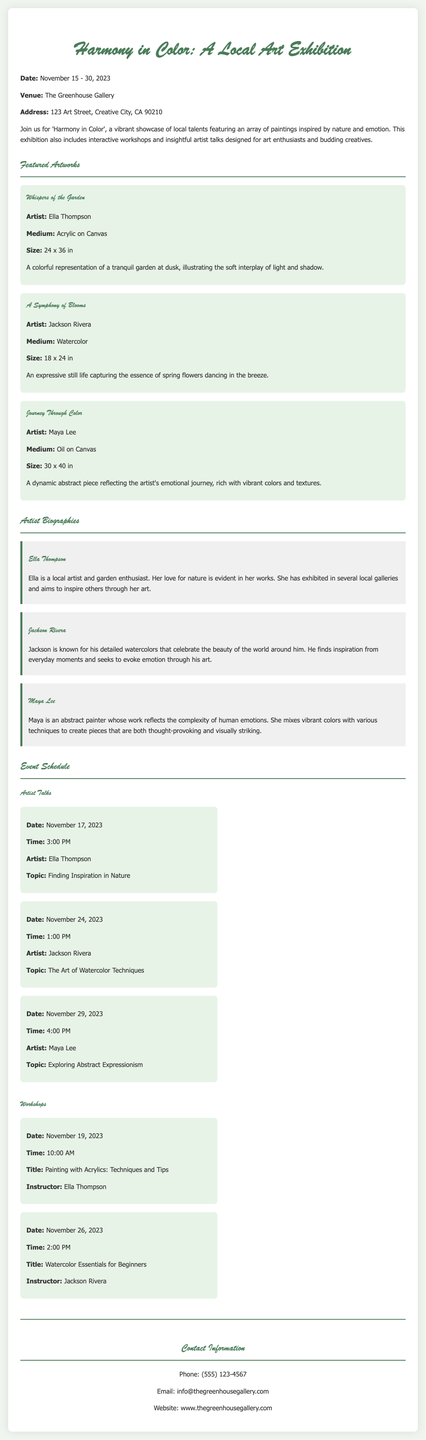What are the dates of the exhibition? The exhibition runs from November 15 to 30, 2023, as mentioned in the introduction.
Answer: November 15 - 30, 2023 Where is the exhibition taking place? The venue is specified in the document as The Greenhouse Gallery.
Answer: The Greenhouse Gallery Who is the artist of "Journey Through Color"? The document lists the artist of this artwork as Maya Lee.
Answer: Maya Lee What is the topic of Jackson Rivera's artist talk? The topic is provided in the schedule section under his name.
Answer: The Art of Watercolor Techniques What date is the workshop on watercolor essentials? The date is mentioned in the workshops schedule section.
Answer: November 26, 2023 Which medium is used for "Whispers of the Garden"? The medium is specified in the description of the artwork.
Answer: Acrylic on Canvas How many artist talks are scheduled? The document lists three artist talks in the schedule section.
Answer: Three What is the instructor's name for the acrylics workshop? The instructor is clearly mentioned in the workshop details for that session.
Answer: Ella Thompson What is the size of "A Symphony of Blooms"? The size is provided in the artwork description section.
Answer: 18 x 24 in 